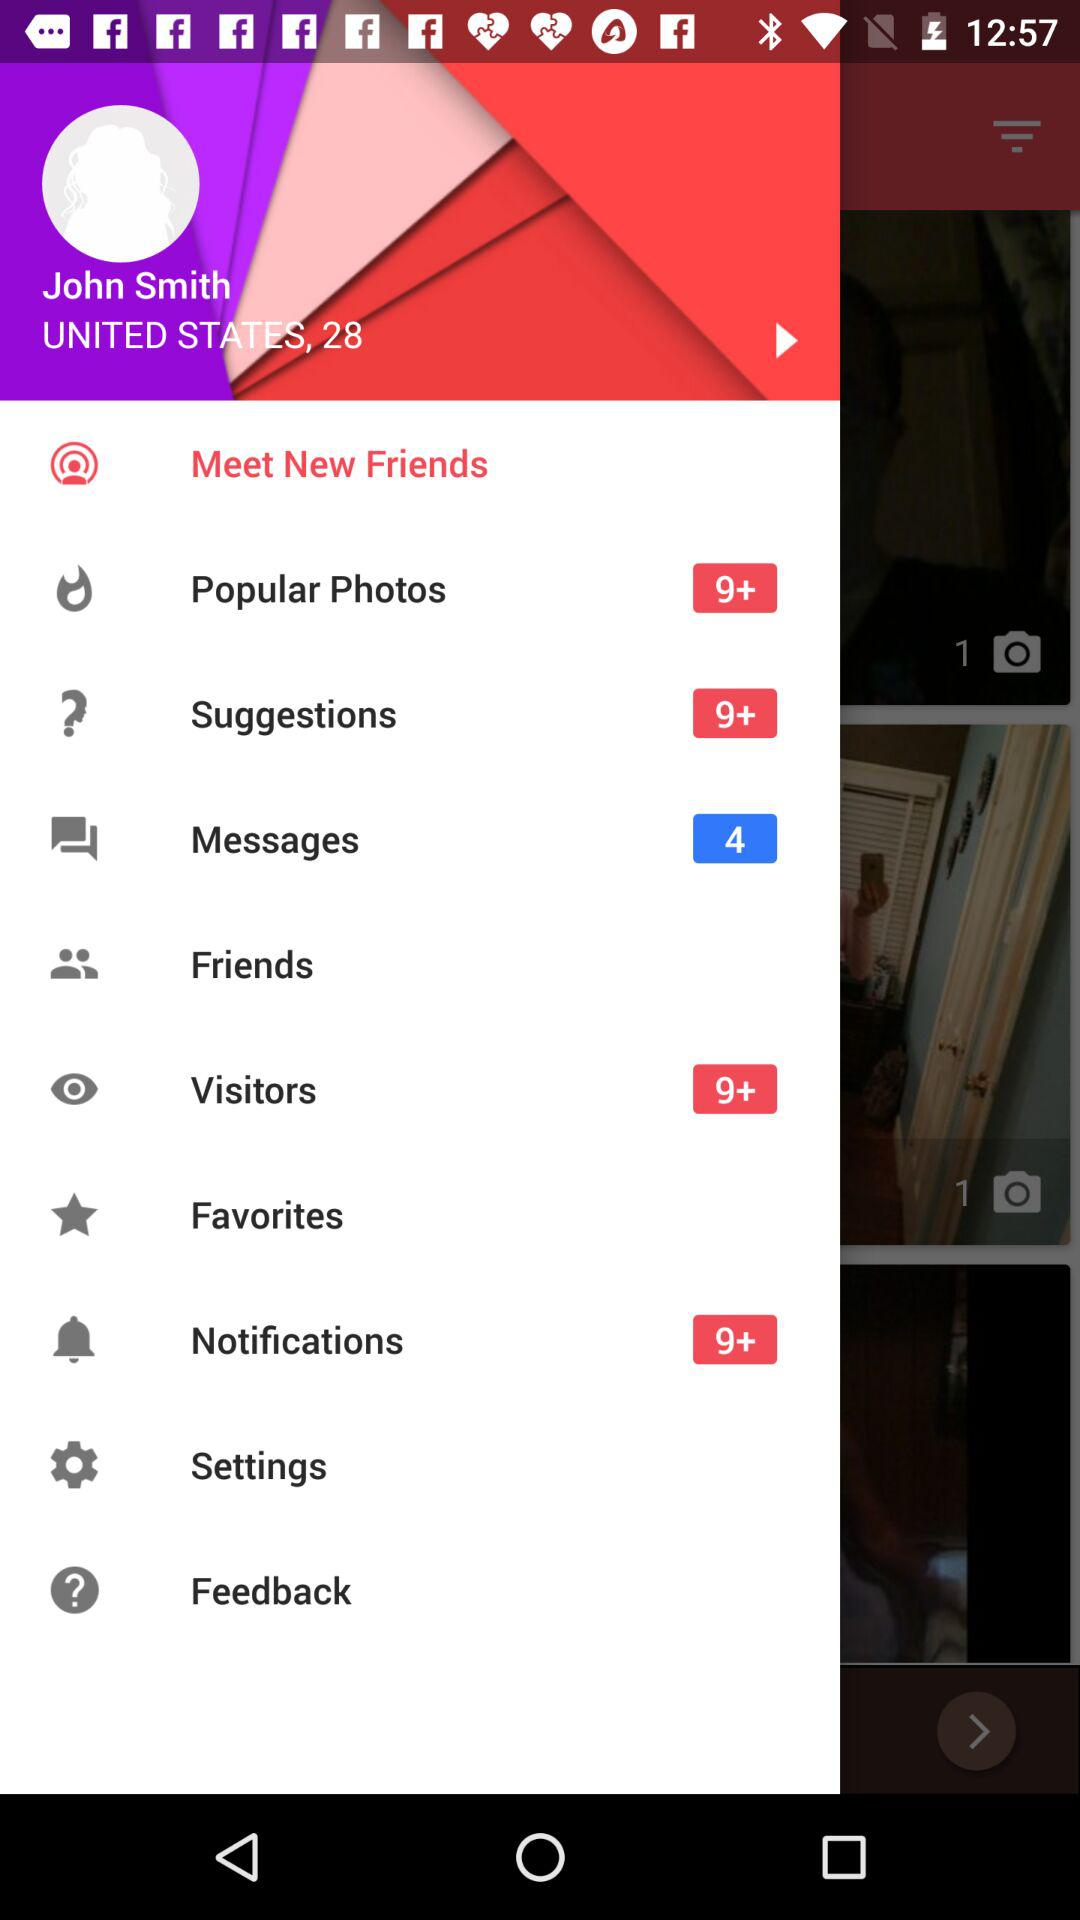What is the age of the user? The user is 28 years old. 